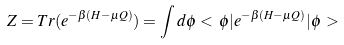<formula> <loc_0><loc_0><loc_500><loc_500>Z = T r ( e ^ { - \beta ( H - \mu Q ) } ) = \int d \phi < \, \phi | e ^ { - \beta ( H - \mu Q ) } | \phi \, ></formula> 